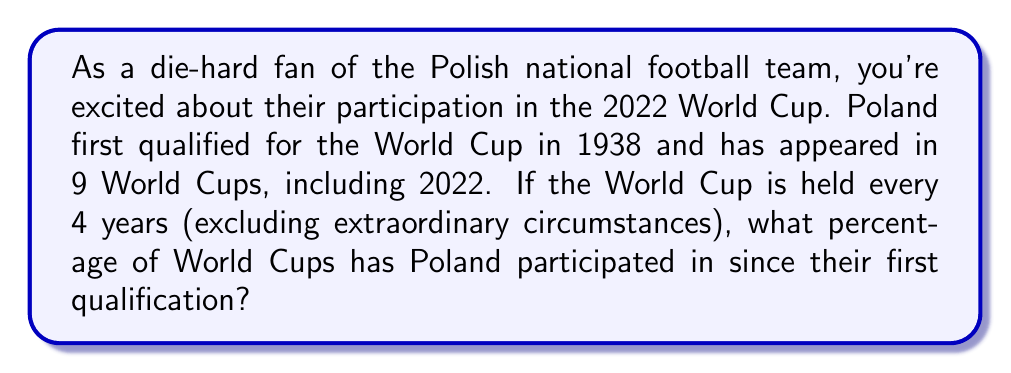What is the answer to this math problem? To solve this problem, we need to follow these steps:

1. Calculate the total number of World Cups since Poland's first qualification:
   - First year of qualification: 1938
   - Most recent World Cup: 2022
   - Number of years: $2022 - 1938 + 1 = 85$ (including both 1938 and 2022)
   - Number of World Cups: $\frac{85}{4} = 21.25$, which rounds up to 22 World Cups

2. We know Poland has participated in 9 World Cups.

3. Calculate the percentage:
   $$\text{Percentage} = \frac{\text{Number of participations}}{\text{Total number of World Cups}} \times 100\%$$
   $$= \frac{9}{22} \times 100\%$$
   $$= 0.4090909091 \times 100\%$$
   $$= 40.90909091\%$$

4. Round to two decimal places:
   $40.91\%$

Therefore, Poland has participated in approximately 40.91% of World Cups since their first qualification.
Answer: $40.91\%$ 